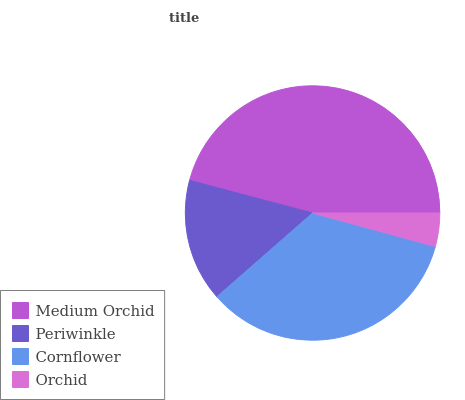Is Orchid the minimum?
Answer yes or no. Yes. Is Medium Orchid the maximum?
Answer yes or no. Yes. Is Periwinkle the minimum?
Answer yes or no. No. Is Periwinkle the maximum?
Answer yes or no. No. Is Medium Orchid greater than Periwinkle?
Answer yes or no. Yes. Is Periwinkle less than Medium Orchid?
Answer yes or no. Yes. Is Periwinkle greater than Medium Orchid?
Answer yes or no. No. Is Medium Orchid less than Periwinkle?
Answer yes or no. No. Is Cornflower the high median?
Answer yes or no. Yes. Is Periwinkle the low median?
Answer yes or no. Yes. Is Medium Orchid the high median?
Answer yes or no. No. Is Cornflower the low median?
Answer yes or no. No. 